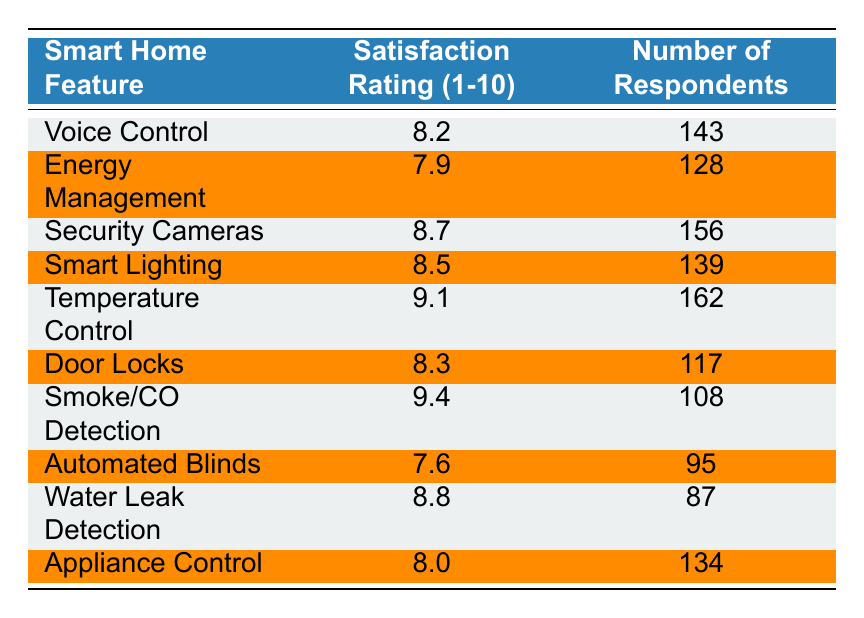What is the satisfaction rating for Security Cameras? The table shows that the satisfaction rating for Security Cameras is listed under the "Satisfaction Rating (1-10)" column corresponding to that feature. The value in that row is 8.7.
Answer: 8.7 Which smart home feature has the highest satisfaction rating? By examining the "Satisfaction Rating (1-10)" column, I identify the highest value. Temperature Control has a rating of 9.1, which is higher than all other features listed.
Answer: Temperature Control What is the average satisfaction rating of all features combined? To calculate the average, I sum all the satisfaction ratings: (8.2 + 7.9 + 8.7 + 8.5 + 9.1 + 8.3 + 9.4 + 7.6 + 8.8 + 8.0) = 88.5. Then I divide by the total number of features, which is 10, giving me 88.5 / 10 = 8.85.
Answer: 8.85 Did more respondents rate the Temperature Control feature than the Energy Management feature? I check the "Number of Respondents" for both Temperature Control and Energy Management. Temperature Control has 162 respondents while Energy Management has 128 respondents. Since 162 is greater than 128, the answer is yes.
Answer: Yes What is the difference in satisfaction ratings between Smoke/CO Detection and Automated Blinds? I first find the ratings for both features: Smoke/CO Detection is 9.4 and Automated Blinds is 7.6. To find the difference, I subtract 7.6 from 9.4: 9.4 - 7.6 = 1.8.
Answer: 1.8 How many respondents rated the Appliance Control? The table provides a clear count of respondents for Appliance Control in the "Number of Respondents" column, which shows the number as 134.
Answer: 134 Is the average satisfaction rating for features with more than 140 respondents higher than 8? First, identify the features with more than 140 respondents, which are Voice Control (143), Security Cameras (156), Smart Lighting (139), Temperature Control (162), and Appliance Control (134). Next, sum their ratings: 8.2 + 8.7 + 8.5 + 9.1 + 8.0 = 42.5. There are 5 features, so the average is 42.5 / 5 = 8.5, which is indeed higher than 8.
Answer: Yes Which feature has the lowest satisfaction rating, and what is that rating? Looking at the "Satisfaction Rating (1-10)" column, I can see that Automated Blinds has the lowest rating at 7.6 when compared to the other features listed in the table.
Answer: Automated Blinds, 7.6 If I combine the respondents for Smoke/CO Detection and Water Leak Detection, how many total respondents does that yield? I locate the number of respondents for both features: Smoke/CO Detection has 108 respondents, and Water Leak Detection has 87. Adding them together gives 108 + 87 = 195.
Answer: 195 